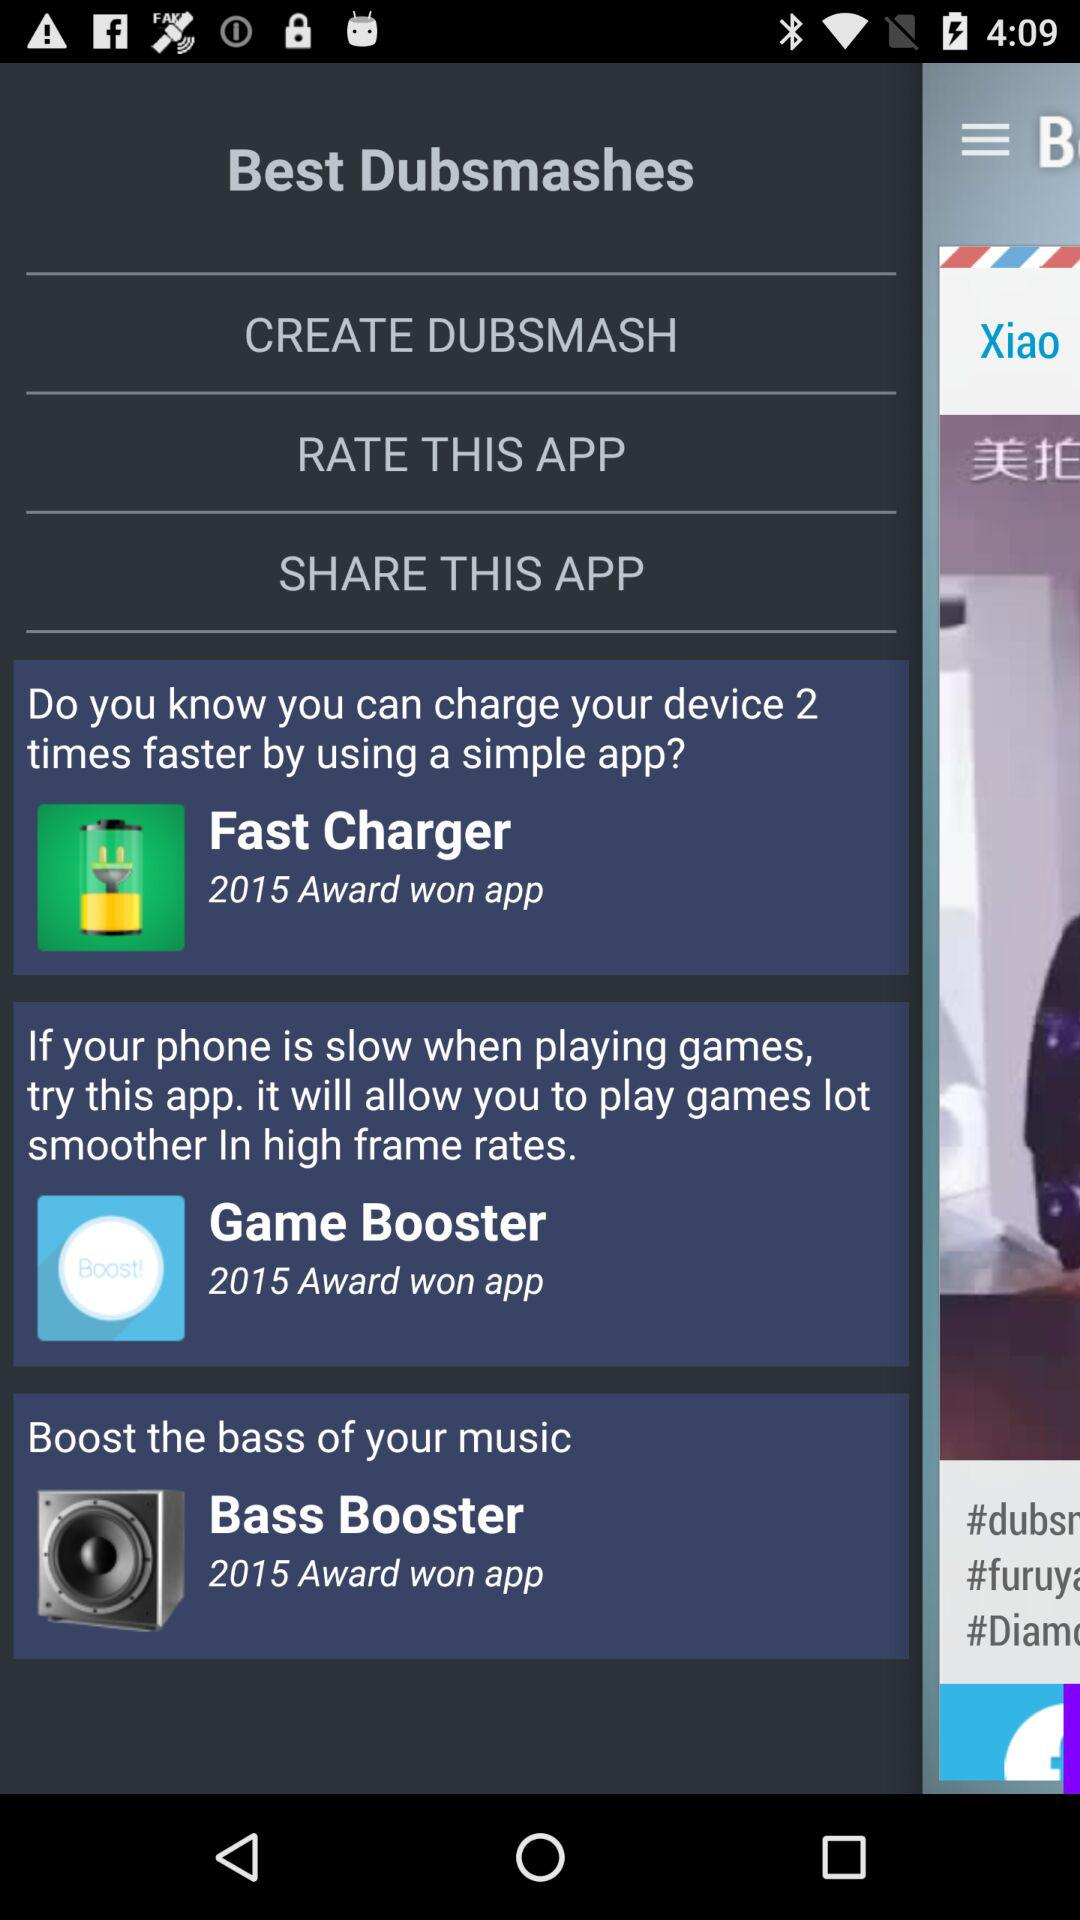How many award-winning apps are there?
Answer the question using a single word or phrase. 3 